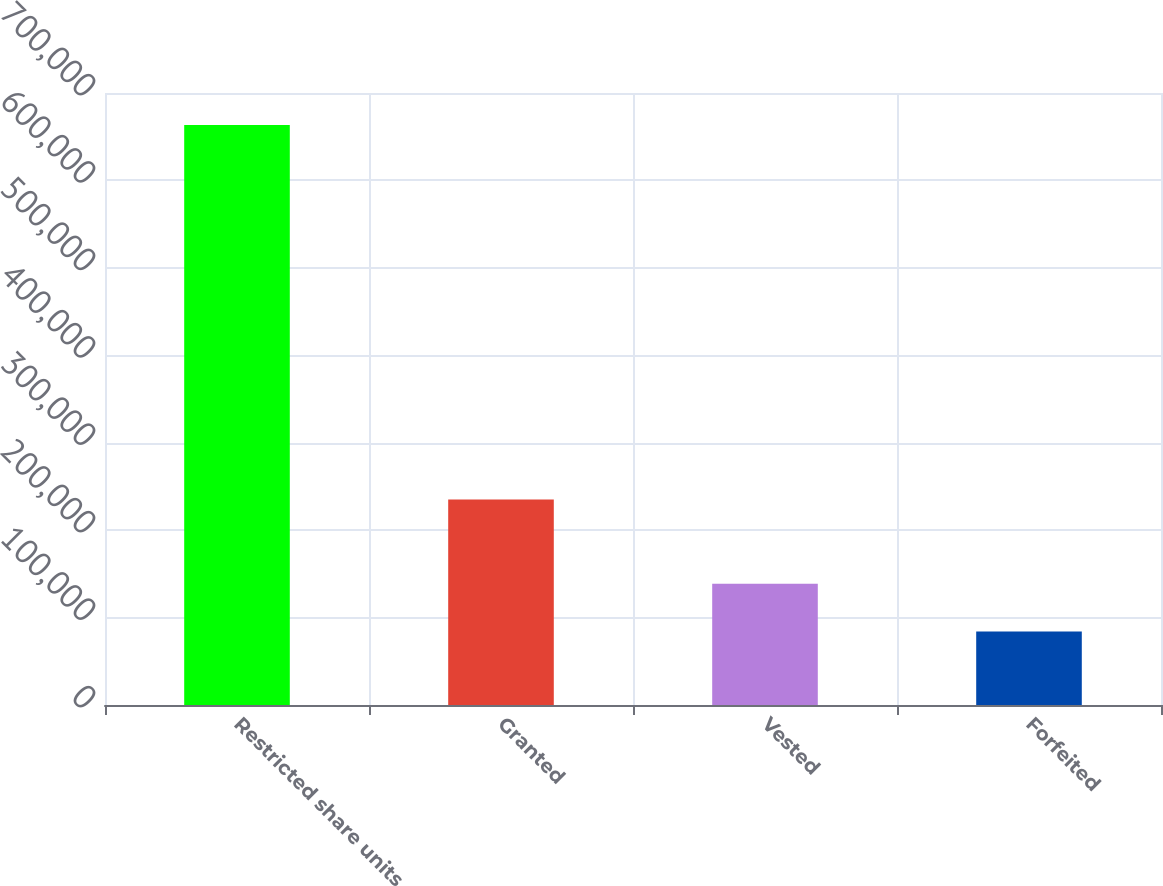Convert chart. <chart><loc_0><loc_0><loc_500><loc_500><bar_chart><fcel>Restricted share units<fcel>Granted<fcel>Vested<fcel>Forfeited<nl><fcel>663376<fcel>234975<fcel>138740<fcel>84132<nl></chart> 